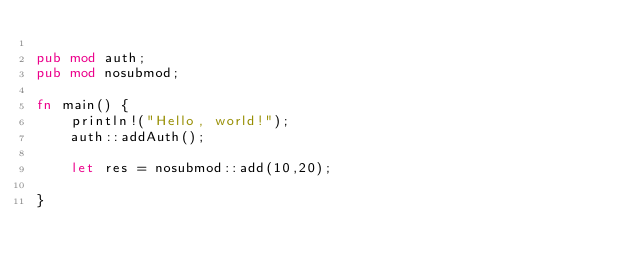Convert code to text. <code><loc_0><loc_0><loc_500><loc_500><_Rust_>
pub mod auth;
pub mod nosubmod;

fn main() {
    println!("Hello, world!");
    auth::addAuth();
 
    let res = nosubmod::add(10,20);

}
</code> 